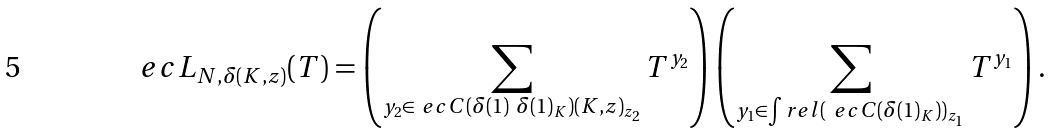Convert formula to latex. <formula><loc_0><loc_0><loc_500><loc_500>\ e c L _ { N , \delta ( K , z ) } ( T ) = \left ( \sum _ { \substack { y _ { 2 } \in \ e c C ( \delta ( 1 ) \ \delta ( 1 ) _ { K } ) ( K , z ) _ { z _ { 2 } } } } T ^ { y _ { 2 } } \right ) \left ( \sum _ { \substack { y _ { 1 } \in \int r e l ( \ e c C ( \delta ( 1 ) _ { K } ) ) _ { z _ { 1 } } } } T ^ { y _ { 1 } } \right ) .</formula> 